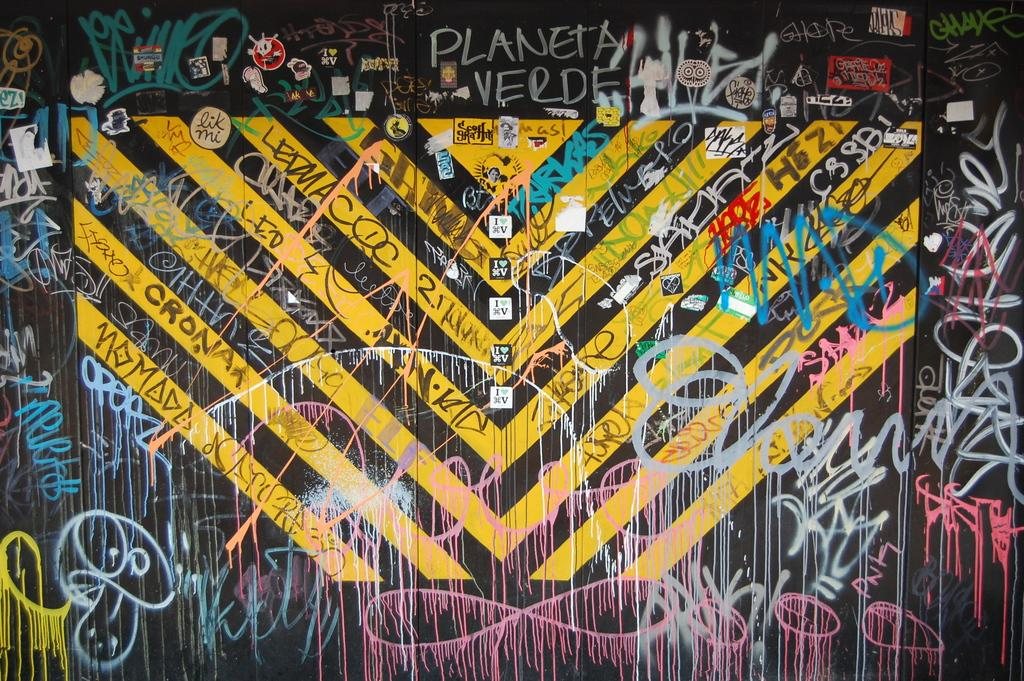<image>
Create a compact narrative representing the image presented. A graffiti wall has text of Planeta Verde at the top. 